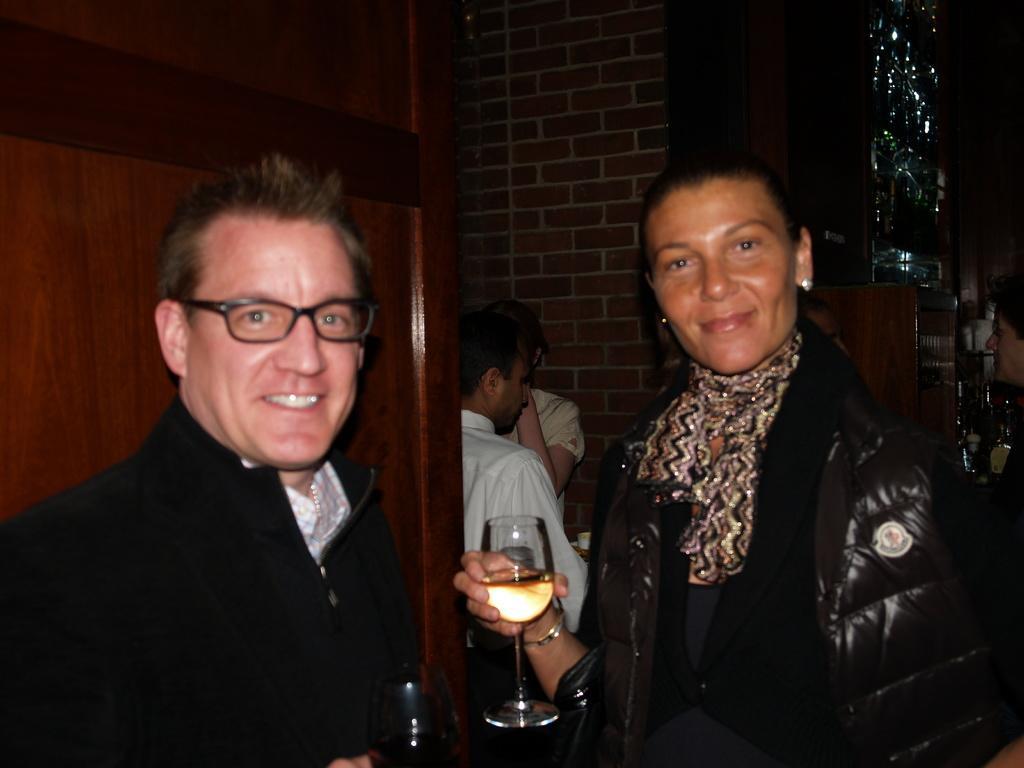In one or two sentences, can you explain what this image depicts? There are two persons standing and holding a wine glass in their hand and there are two people standing in the background. 